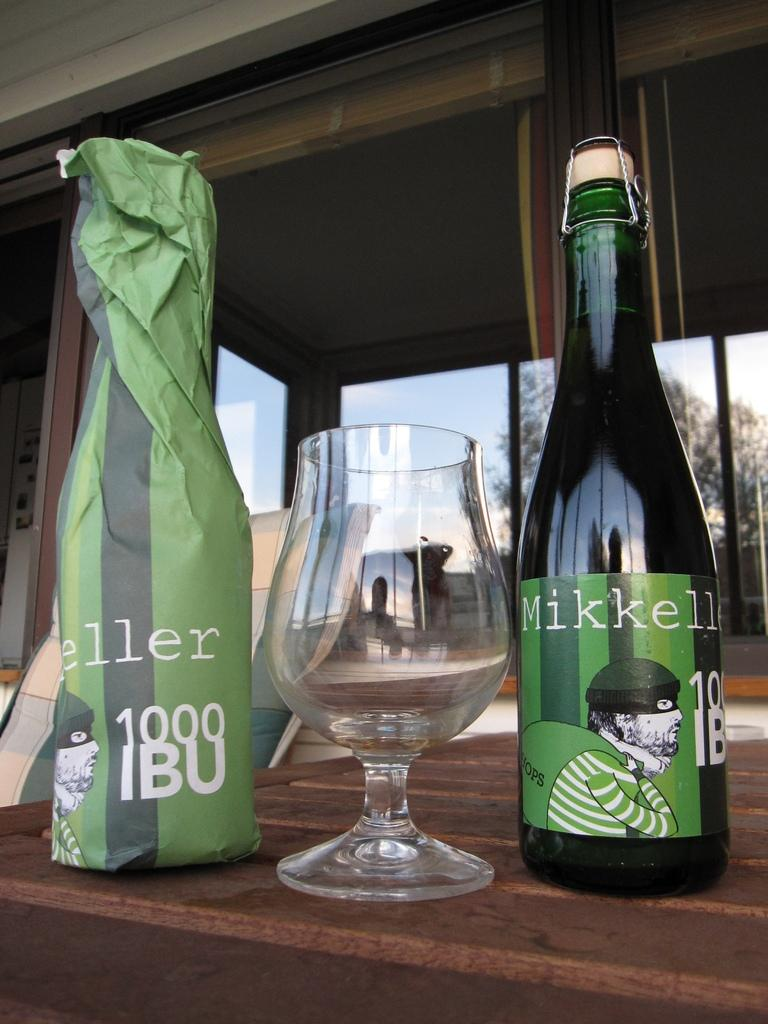What is on the table in the image? There is a bottle and an empty glass on the table. What can be seen in the background of the image? There is a window in the background. What type of cup is being used to make a selection in the image? There is no cup or selection process depicted in the image. 